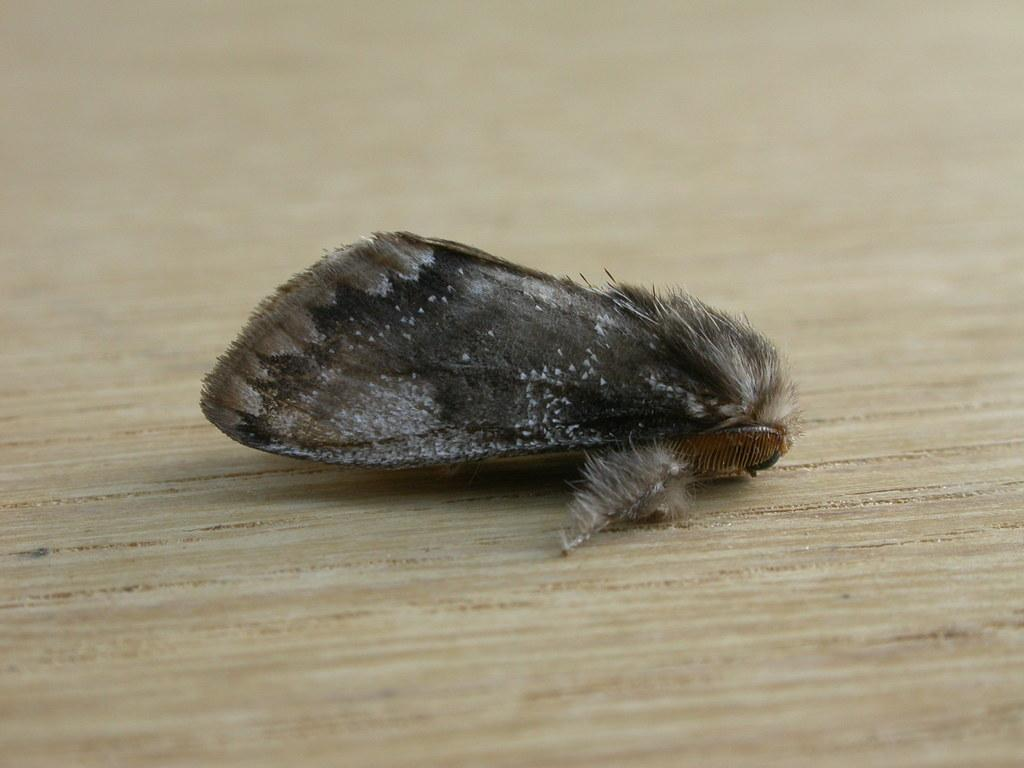What type of insect is in the image? There is a brown house moth in the image. Where is the moth located in the image? The moth is on a surface. How many boys are interacting with the police in the image? There are no boys or police present in the image; it only features a brown house moth on a surface. What type of cheese is visible in the image? There is no cheese present in the image; it only features a brown house moth on a surface. 